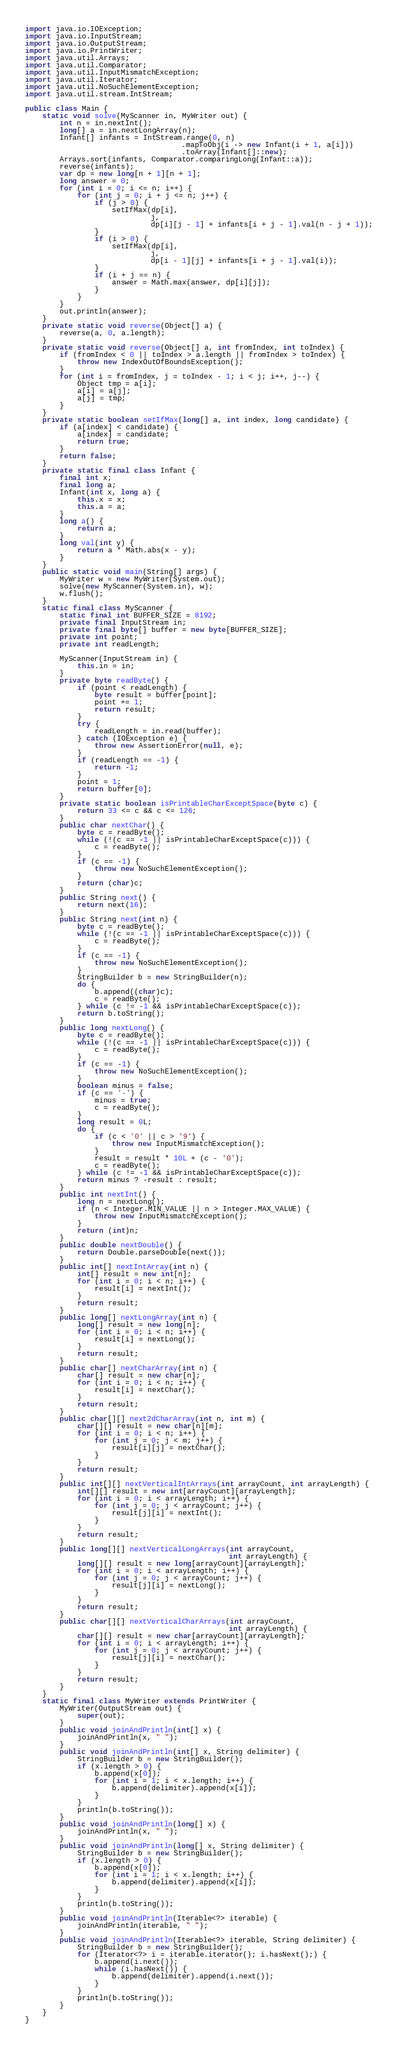Convert code to text. <code><loc_0><loc_0><loc_500><loc_500><_Java_>import java.io.IOException;
import java.io.InputStream;
import java.io.OutputStream;
import java.io.PrintWriter;
import java.util.Arrays;
import java.util.Comparator;
import java.util.InputMismatchException;
import java.util.Iterator;
import java.util.NoSuchElementException;
import java.util.stream.IntStream;

public class Main {
    static void solve(MyScanner in, MyWriter out) {
        int n = in.nextInt();
        long[] a = in.nextLongArray(n);
        Infant[] infants = IntStream.range(0, n)
                                    .mapToObj(i -> new Infant(i + 1, a[i]))
                                    .toArray(Infant[]::new);
        Arrays.sort(infants, Comparator.comparingLong(Infant::a));
        reverse(infants);
        var dp = new long[n + 1][n + 1];
        long answer = 0;
        for (int i = 0; i <= n; i++) {
            for (int j = 0; i + j <= n; j++) {
                if (j > 0) {
                    setIfMax(dp[i],
                             j,
                             dp[i][j - 1] + infants[i + j - 1].val(n - j + 1));
                }
                if (i > 0) {
                    setIfMax(dp[i],
                             j,
                             dp[i - 1][j] + infants[i + j - 1].val(i));
                }
                if (i + j == n) {
                    answer = Math.max(answer, dp[i][j]);
                }
            }
        }
        out.println(answer);
    }
    private static void reverse(Object[] a) {
        reverse(a, 0, a.length);
    }
    private static void reverse(Object[] a, int fromIndex, int toIndex) {
        if (fromIndex < 0 || toIndex > a.length || fromIndex > toIndex) {
            throw new IndexOutOfBoundsException();
        }
        for (int i = fromIndex, j = toIndex - 1; i < j; i++, j--) {
            Object tmp = a[i];
            a[i] = a[j];
            a[j] = tmp;
        }
    }
    private static boolean setIfMax(long[] a, int index, long candidate) {
        if (a[index] < candidate) {
            a[index] = candidate;
            return true;
        }
        return false;
    }
    private static final class Infant {
        final int x;
        final long a;
        Infant(int x, long a) {
            this.x = x;
            this.a = a;
        }
        long a() {
            return a;
        }
        long val(int y) {
            return a * Math.abs(x - y);
        }
    }
    public static void main(String[] args) {
        MyWriter w = new MyWriter(System.out);
        solve(new MyScanner(System.in), w);
        w.flush();
    }
    static final class MyScanner {
        static final int BUFFER_SIZE = 8192;
        private final InputStream in;
        private final byte[] buffer = new byte[BUFFER_SIZE];
        private int point;
        private int readLength;

        MyScanner(InputStream in) {
            this.in = in;
        }
        private byte readByte() {
            if (point < readLength) {
                byte result = buffer[point];
                point += 1;
                return result;
            }
            try {
                readLength = in.read(buffer);
            } catch (IOException e) {
                throw new AssertionError(null, e);
            }
            if (readLength == -1) {
                return -1;
            }
            point = 1;
            return buffer[0];
        }
        private static boolean isPrintableCharExceptSpace(byte c) {
            return 33 <= c && c <= 126;
        }
        public char nextChar() {
            byte c = readByte();
            while (!(c == -1 || isPrintableCharExceptSpace(c))) {
                c = readByte();
            }
            if (c == -1) {
                throw new NoSuchElementException();
            }
            return (char)c;
        }
        public String next() {
            return next(16);
        }
        public String next(int n) {
            byte c = readByte();
            while (!(c == -1 || isPrintableCharExceptSpace(c))) {
                c = readByte();
            }
            if (c == -1) {
                throw new NoSuchElementException();
            }
            StringBuilder b = new StringBuilder(n);
            do {
                b.append((char)c);
                c = readByte();
            } while (c != -1 && isPrintableCharExceptSpace(c));
            return b.toString();
        }
        public long nextLong() {
            byte c = readByte();
            while (!(c == -1 || isPrintableCharExceptSpace(c))) {
                c = readByte();
            }
            if (c == -1) {
                throw new NoSuchElementException();
            }
            boolean minus = false;
            if (c == '-') {
                minus = true;
                c = readByte();
            }
            long result = 0L;
            do {
                if (c < '0' || c > '9') {
                    throw new InputMismatchException();
                }
                result = result * 10L + (c - '0');
                c = readByte();
            } while (c != -1 && isPrintableCharExceptSpace(c));
            return minus ? -result : result;
        }
        public int nextInt() {
            long n = nextLong();
            if (n < Integer.MIN_VALUE || n > Integer.MAX_VALUE) {
                throw new InputMismatchException();
            }
            return (int)n;
        }
        public double nextDouble() {
            return Double.parseDouble(next());
        }
        public int[] nextIntArray(int n) {
            int[] result = new int[n];
            for (int i = 0; i < n; i++) {
                result[i] = nextInt();
            }
            return result;
        }
        public long[] nextLongArray(int n) {
            long[] result = new long[n];
            for (int i = 0; i < n; i++) {
                result[i] = nextLong();
            }
            return result;
        }
        public char[] nextCharArray(int n) {
            char[] result = new char[n];
            for (int i = 0; i < n; i++) {
                result[i] = nextChar();
            }
            return result;
        }
        public char[][] next2dCharArray(int n, int m) {
            char[][] result = new char[n][m];
            for (int i = 0; i < n; i++) {
                for (int j = 0; j < m; j++) {
                    result[i][j] = nextChar();
                }
            }
            return result;
        }
        public int[][] nextVerticalIntArrays(int arrayCount, int arrayLength) {
            int[][] result = new int[arrayCount][arrayLength];
            for (int i = 0; i < arrayLength; i++) {
                for (int j = 0; j < arrayCount; j++) {
                    result[j][i] = nextInt();
                }
            }
            return result;
        }
        public long[][] nextVerticalLongArrays(int arrayCount,
                                               int arrayLength) {
            long[][] result = new long[arrayCount][arrayLength];
            for (int i = 0; i < arrayLength; i++) {
                for (int j = 0; j < arrayCount; j++) {
                    result[j][i] = nextLong();
                }
            }
            return result;
        }
        public char[][] nextVerticalCharArrays(int arrayCount,
                                               int arrayLength) {
            char[][] result = new char[arrayCount][arrayLength];
            for (int i = 0; i < arrayLength; i++) {
                for (int j = 0; j < arrayCount; j++) {
                    result[j][i] = nextChar();
                }
            }
            return result;
        }
    }
    static final class MyWriter extends PrintWriter {
        MyWriter(OutputStream out) {
            super(out);
        }
        public void joinAndPrintln(int[] x) {
            joinAndPrintln(x, " ");
        }
        public void joinAndPrintln(int[] x, String delimiter) {
            StringBuilder b = new StringBuilder();
            if (x.length > 0) {
                b.append(x[0]);
                for (int i = 1; i < x.length; i++) {
                    b.append(delimiter).append(x[i]);
                }
            }
            println(b.toString());
        }
        public void joinAndPrintln(long[] x) {
            joinAndPrintln(x, " ");
        }
        public void joinAndPrintln(long[] x, String delimiter) {
            StringBuilder b = new StringBuilder();
            if (x.length > 0) {
                b.append(x[0]);
                for (int i = 1; i < x.length; i++) {
                    b.append(delimiter).append(x[i]);
                }
            }
            println(b.toString());
        }
        public void joinAndPrintln(Iterable<?> iterable) {
            joinAndPrintln(iterable, " ");
        }
        public void joinAndPrintln(Iterable<?> iterable, String delimiter) {
            StringBuilder b = new StringBuilder();
            for (Iterator<?> i = iterable.iterator(); i.hasNext();) {
                b.append(i.next());
                while (i.hasNext()) {
                    b.append(delimiter).append(i.next());
                }
            }
            println(b.toString());
        }
    }
}
</code> 